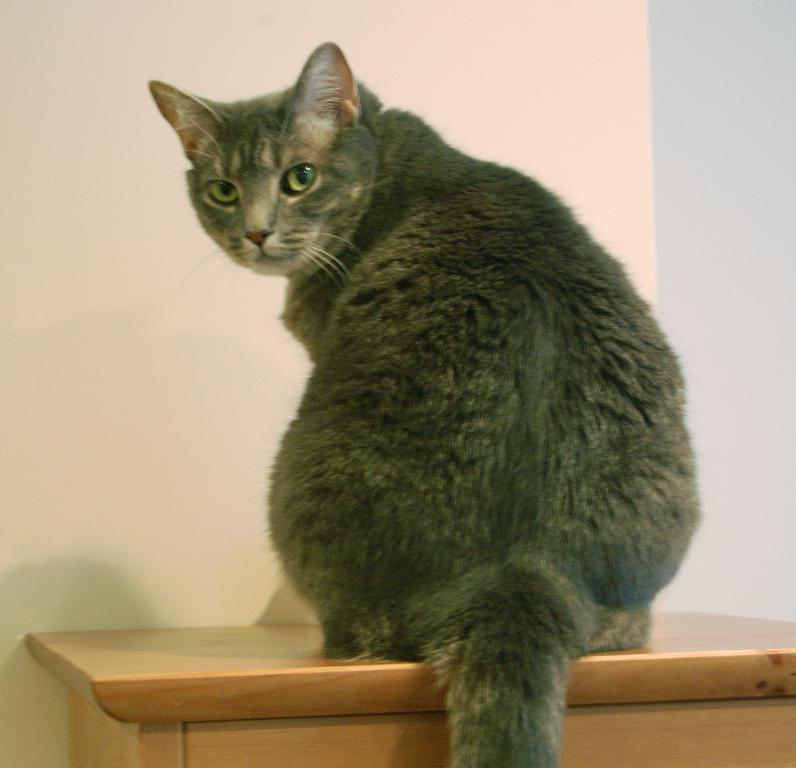What animal is present in the image? There is a cat in the image. Where is the cat located? The cat is on a table in the image. What can be seen in the background of the image? There is a wall in the image. How many yaks are visible in the image? There are no yaks present in the image. What type of division is taking place in the image? There is no division or separation of any kind depicted in the image. 